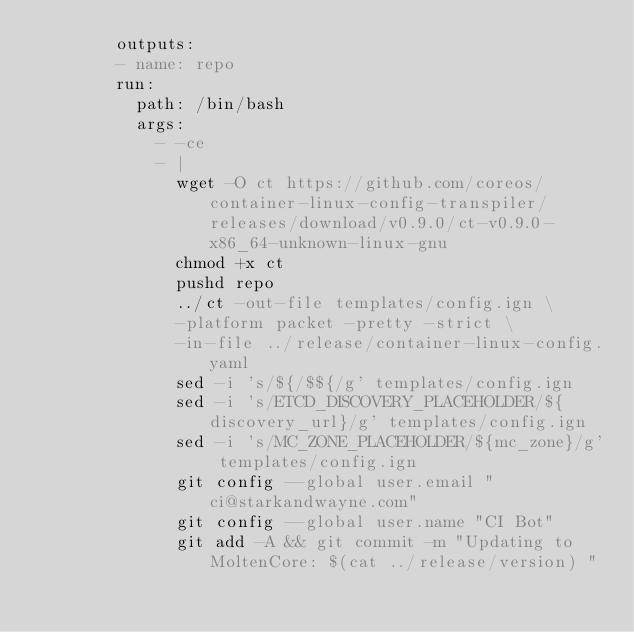Convert code to text. <code><loc_0><loc_0><loc_500><loc_500><_YAML_>        outputs:
        - name: repo
        run:
          path: /bin/bash
          args:
            - -ce
            - |
              wget -O ct https://github.com/coreos/container-linux-config-transpiler/releases/download/v0.9.0/ct-v0.9.0-x86_64-unknown-linux-gnu
              chmod +x ct
              pushd repo
              ../ct -out-file templates/config.ign \
              -platform packet -pretty -strict \
              -in-file ../release/container-linux-config.yaml
              sed -i 's/${/$${/g' templates/config.ign
              sed -i 's/ETCD_DISCOVERY_PLACEHOLDER/${discovery_url}/g' templates/config.ign
              sed -i 's/MC_ZONE_PLACEHOLDER/${mc_zone}/g' templates/config.ign
              git config --global user.email "ci@starkandwayne.com"
              git config --global user.name "CI Bot"
              git add -A && git commit -m "Updating to MoltenCore: $(cat ../release/version) "</code> 